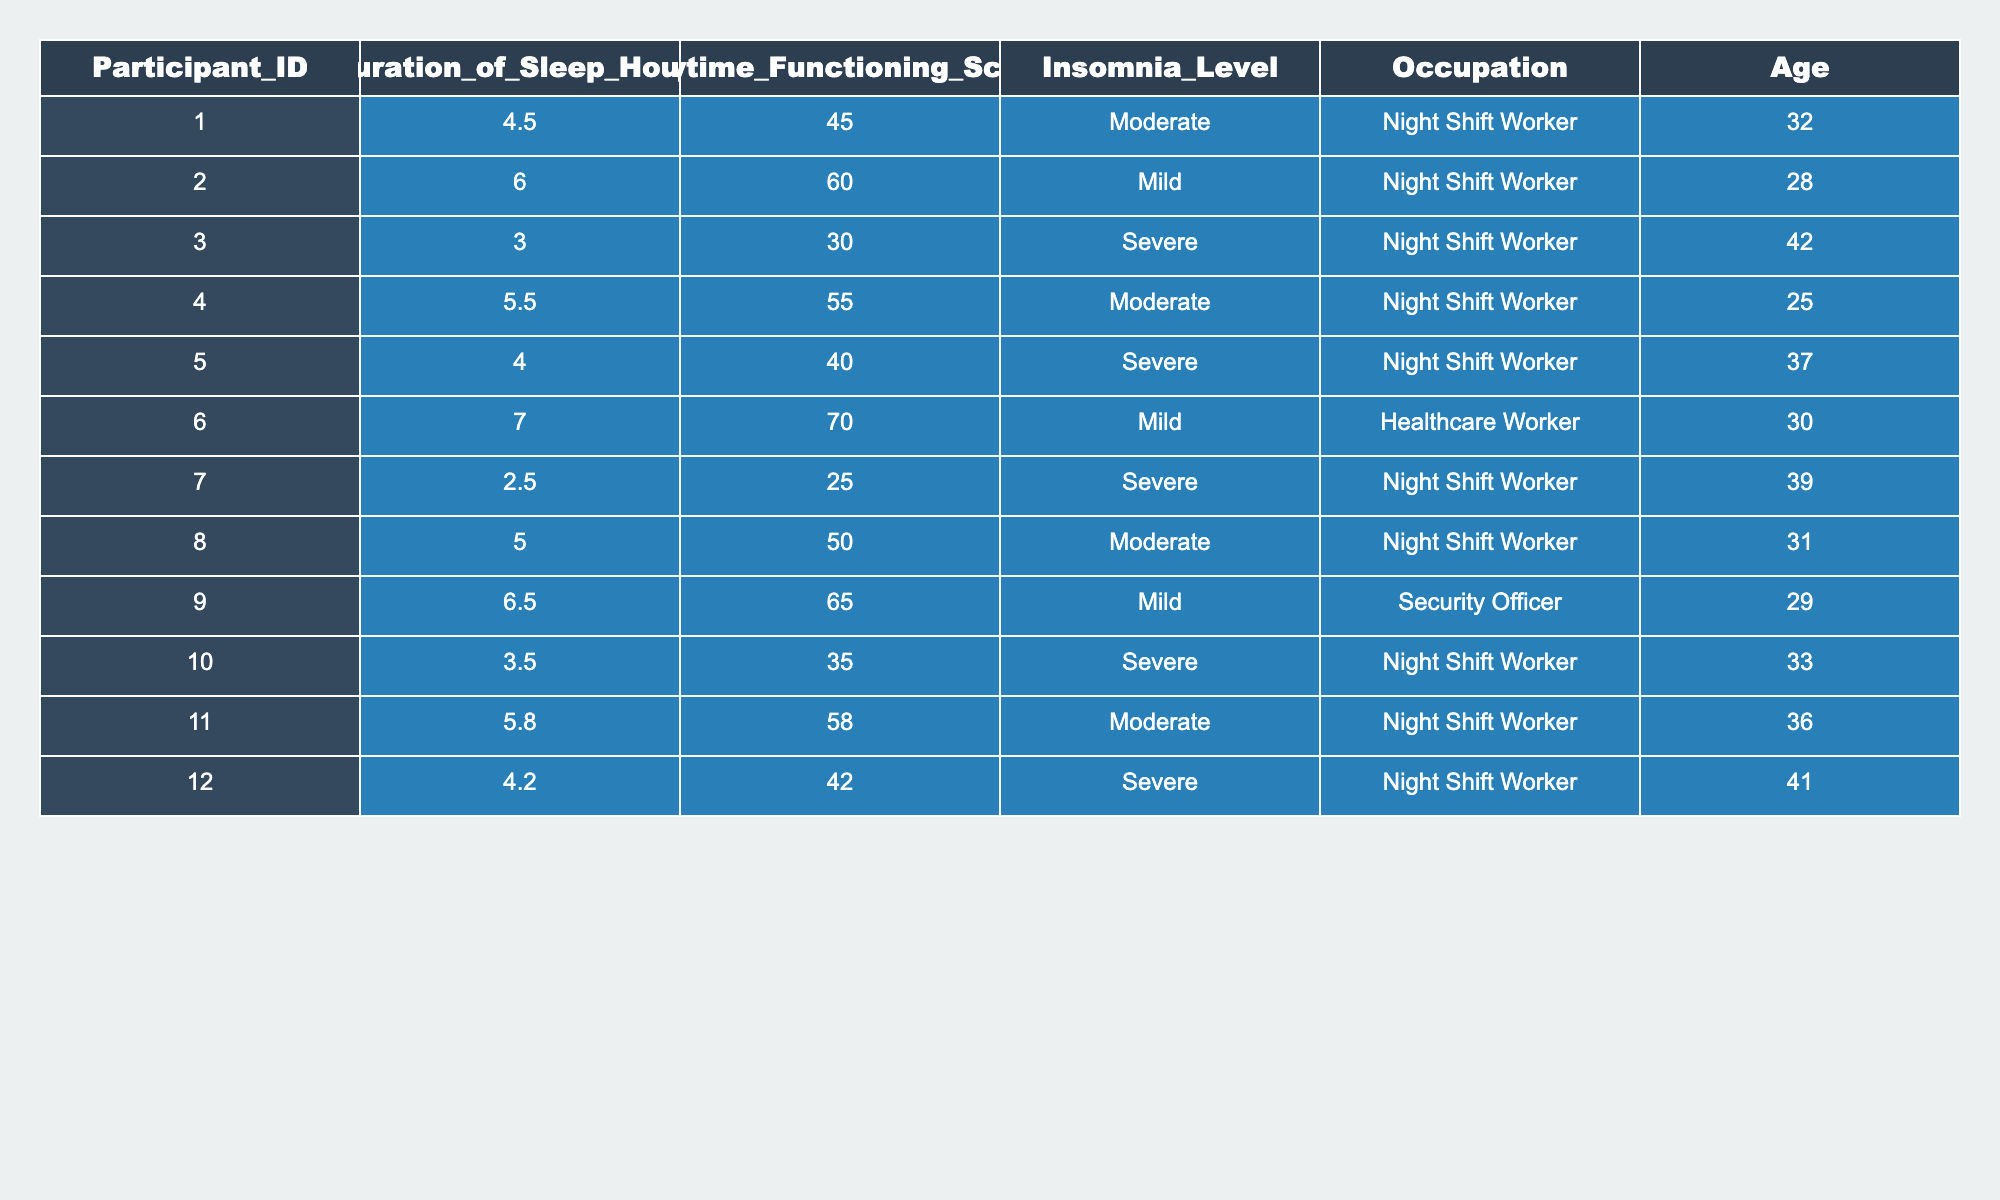What is the duration of sleep for participant 003? From the table, I can directly read the "Duration_of_Sleep_Hours" for participant 003, which is listed as 3.0 hours.
Answer: 3.0 What is the daytime functioning score for the participant who sleeps 6.0 hours? I find the entry with "Duration_of_Sleep_Hours" of 6.0 and see that the corresponding "Daytime_Functioning_Score" for participant 002 is 60.
Answer: 60 Which participant has the lowest daytime functioning score? I look at the "Daytime_Functioning_Score" column and see that participant 007 has the lowest score of 25.
Answer: Participant 007 What is the average duration of sleep for all participants in this study? I add up all the "Duration_of_Sleep_Hours" values: 4.5 + 6.0 + 3.0 + 5.5 + 4.0 + 7.0 + 2.5 + 5.0 + 6.5 + 3.5 + 5.8 + 4.2 = 58.5. There are 12 participants, so the average is 58.5 / 12 = 4.875 hours.
Answer: 4.875 Is there a participant who has a daytime functioning score of 70? I scan the "Daytime_Functioning_Score" column to see if any score equals 70. None of the scores in that column reach 70.
Answer: No Which insomnia level is associated with the highest average daytime functioning score? I calculate the average daytime functioning score for each insomnia level: Moderate (45, 55, 50, 58) = 52, Mild (60, 70, 65) = 65, Severe (30, 40, 25, 35, 42) = 34. The highest average is for Mild at 65.
Answer: Mild How many participants are classified as night shift workers with a severe insomnia level? I count the rows where "Occupation" is "Night Shift Worker" and "Insomnia_Level" is "Severe". There are 4 such participants (003, 005, 007, 010, 012).
Answer: 5 What is the range of ages of participants classified as having moderate insomnia? I look for participants with "Insomnia_Level" as "Moderate": ages are 32, 25, 31, and 36. The range is from 25 to 36.
Answer: 11 Who is the oldest participant in this study? I locate the ages in the table, finding that the oldest is participant 012 at age 41.
Answer: Participant 012 Are there any participants who sleep more than 7 hours? I check the "Duration_of_Sleep_Hours" column, and the maximum value is 7.0. Hence, no participants have sleep duration above 7 hours.
Answer: No 